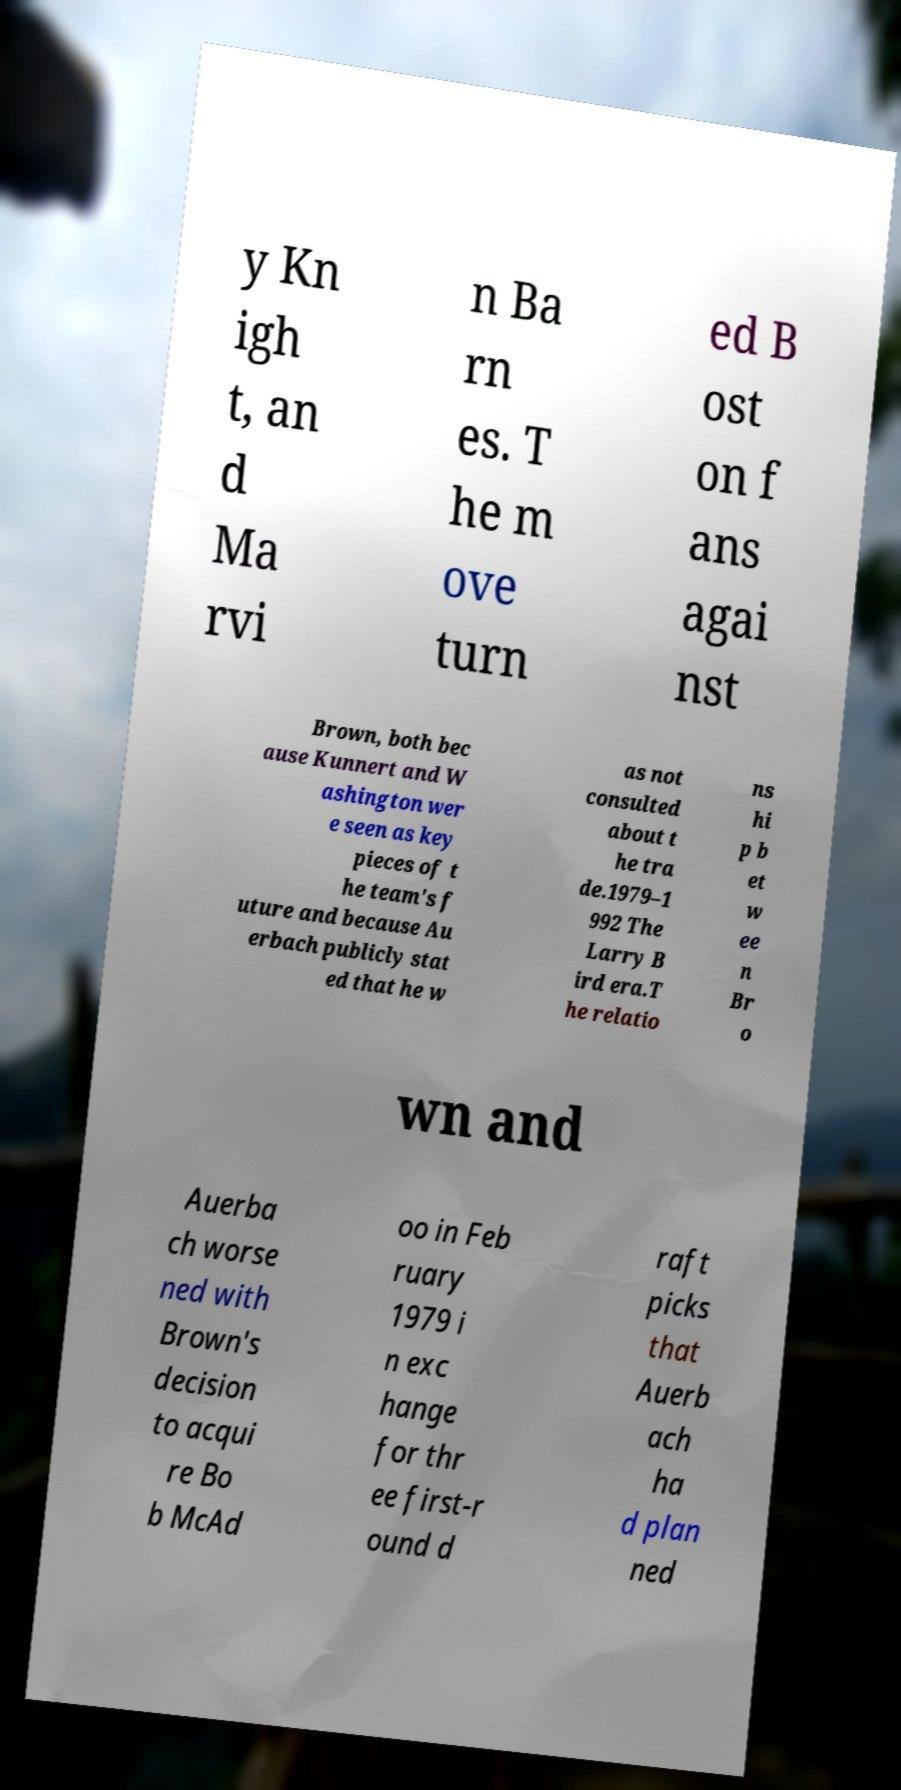I need the written content from this picture converted into text. Can you do that? y Kn igh t, an d Ma rvi n Ba rn es. T he m ove turn ed B ost on f ans agai nst Brown, both bec ause Kunnert and W ashington wer e seen as key pieces of t he team's f uture and because Au erbach publicly stat ed that he w as not consulted about t he tra de.1979–1 992 The Larry B ird era.T he relatio ns hi p b et w ee n Br o wn and Auerba ch worse ned with Brown's decision to acqui re Bo b McAd oo in Feb ruary 1979 i n exc hange for thr ee first-r ound d raft picks that Auerb ach ha d plan ned 